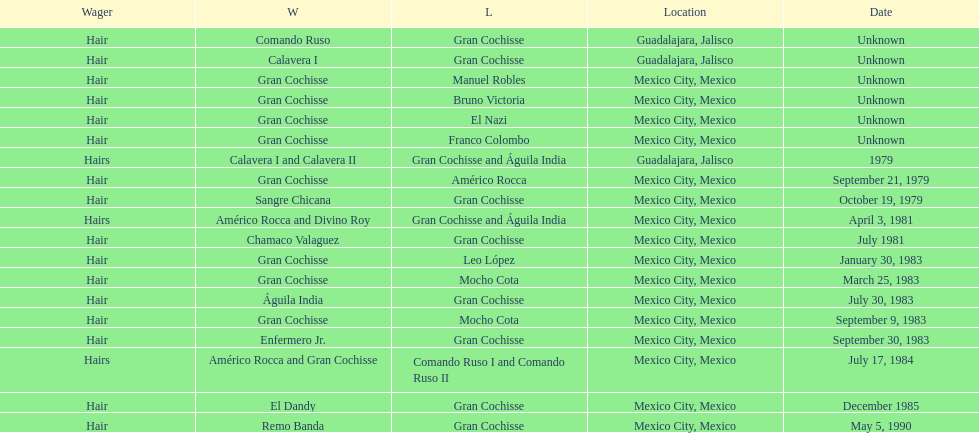When was the first match of gran chochisse with a fully recorded date held? September 21, 1979. 